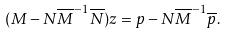<formula> <loc_0><loc_0><loc_500><loc_500>( M - N \overline { M } ^ { - 1 } \overline { N } ) z = p - N \overline { M } ^ { - 1 } \overline { p } .</formula> 